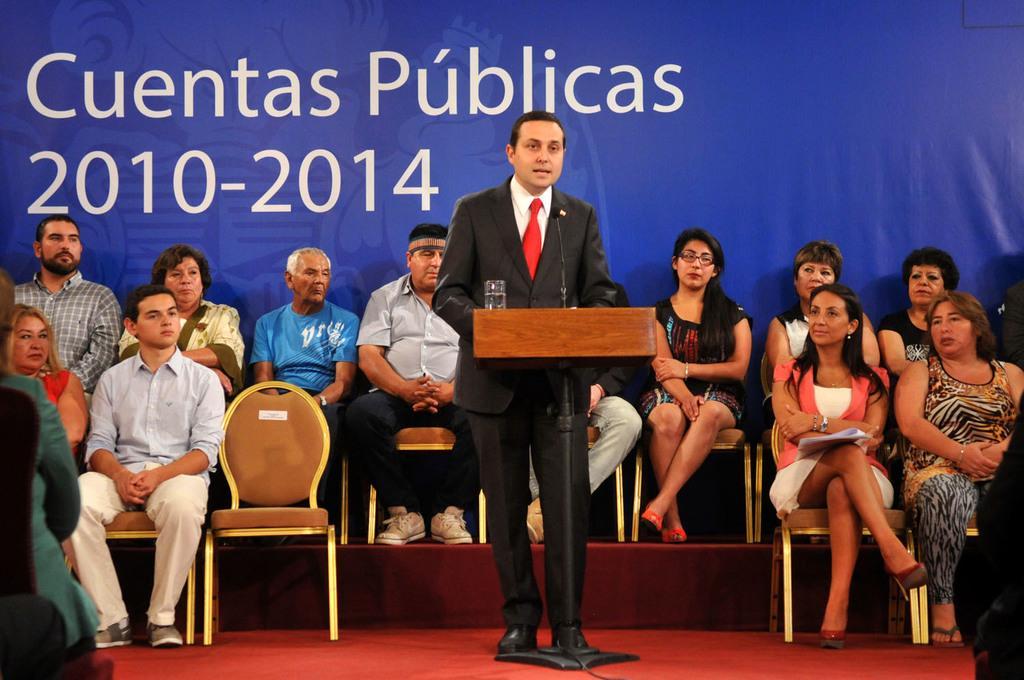Describe this image in one or two sentences. In this image we can see a group of persons sitting on chairs. In the foreground we can see a person standing. In front of the person we can see a stand and on the stand we can see a mic and a glass. In the background, we can see a banner with text. On the left side, we can see a person sitting on a chair. 